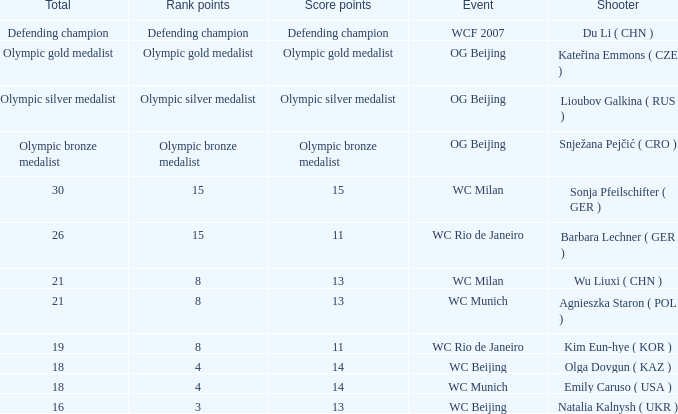Which event had a total of defending champion? WCF 2007. 